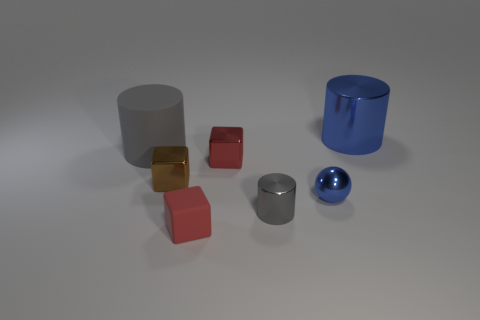What number of objects are both on the right side of the small brown cube and in front of the big gray object?
Provide a succinct answer. 4. There is a block in front of the small metal cylinder; is its color the same as the rubber object behind the tiny shiny cylinder?
Your response must be concise. No. Are there any other things that are the same material as the tiny blue object?
Provide a succinct answer. Yes. What size is the red shiny object that is the same shape as the brown object?
Offer a terse response. Small. There is a tiny gray cylinder; are there any big blue objects in front of it?
Ensure brevity in your answer.  No. Are there the same number of shiny spheres behind the small blue metal ball and big brown matte cubes?
Keep it short and to the point. Yes. Is there a red thing behind the big thing right of the blue object that is in front of the large blue shiny thing?
Make the answer very short. No. What is the tiny blue ball made of?
Give a very brief answer. Metal. How many other things are the same shape as the red metallic thing?
Provide a short and direct response. 2. Do the red metallic object and the tiny gray metal object have the same shape?
Provide a short and direct response. No. 